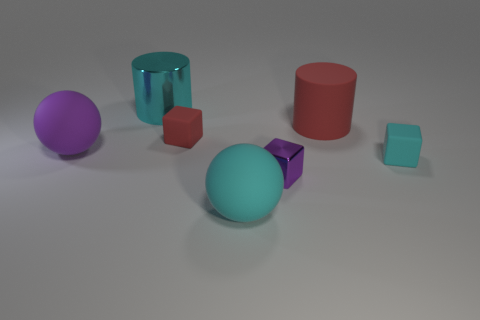Are there fewer large red rubber cylinders on the right side of the red rubber cylinder than small purple metal blocks to the left of the purple metal thing?
Your answer should be compact. No. There is a cyan cylinder; does it have the same size as the block on the right side of the red matte cylinder?
Provide a short and direct response. No. There is a big matte object that is behind the tiny cyan object and to the right of the cyan metal thing; what is its shape?
Ensure brevity in your answer.  Cylinder. What is the size of the block that is the same material as the cyan cylinder?
Offer a very short reply. Small. What number of rubber balls are on the right side of the matte object that is to the right of the red cylinder?
Ensure brevity in your answer.  0. Do the big cyan object that is left of the small red rubber thing and the purple sphere have the same material?
Provide a short and direct response. No. Is there any other thing that is made of the same material as the large purple object?
Give a very brief answer. Yes. What size is the matte ball that is behind the small matte object in front of the red matte cube?
Keep it short and to the point. Large. What size is the matte ball that is to the left of the tiny rubber thing that is to the left of the red object that is right of the large cyan ball?
Your answer should be very brief. Large. There is a cyan thing on the left side of the cyan ball; is it the same shape as the cyan matte thing on the right side of the large rubber cylinder?
Your response must be concise. No. 